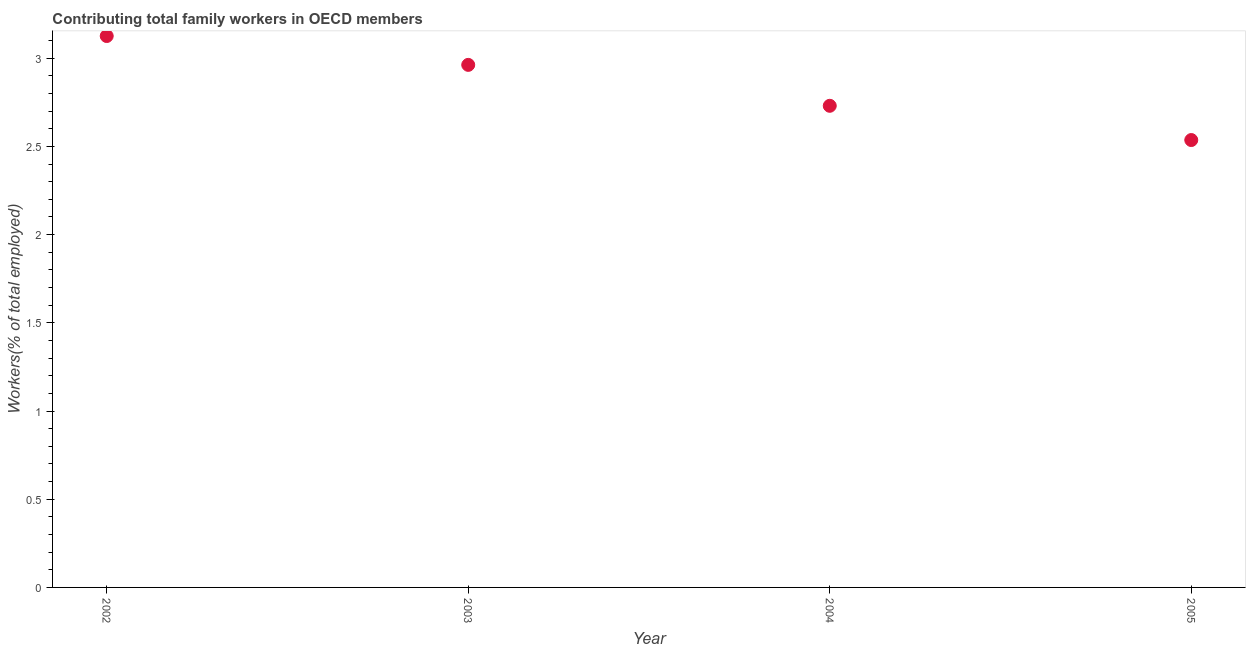What is the contributing family workers in 2004?
Make the answer very short. 2.73. Across all years, what is the maximum contributing family workers?
Keep it short and to the point. 3.13. Across all years, what is the minimum contributing family workers?
Ensure brevity in your answer.  2.54. In which year was the contributing family workers maximum?
Your answer should be very brief. 2002. What is the sum of the contributing family workers?
Offer a very short reply. 11.36. What is the difference between the contributing family workers in 2003 and 2004?
Ensure brevity in your answer.  0.23. What is the average contributing family workers per year?
Provide a succinct answer. 2.84. What is the median contributing family workers?
Provide a short and direct response. 2.85. What is the ratio of the contributing family workers in 2002 to that in 2004?
Your response must be concise. 1.14. Is the contributing family workers in 2003 less than that in 2005?
Offer a very short reply. No. Is the difference between the contributing family workers in 2002 and 2003 greater than the difference between any two years?
Ensure brevity in your answer.  No. What is the difference between the highest and the second highest contributing family workers?
Offer a terse response. 0.16. What is the difference between the highest and the lowest contributing family workers?
Keep it short and to the point. 0.59. Does the contributing family workers monotonically increase over the years?
Keep it short and to the point. No. Does the graph contain grids?
Keep it short and to the point. No. What is the title of the graph?
Keep it short and to the point. Contributing total family workers in OECD members. What is the label or title of the Y-axis?
Provide a succinct answer. Workers(% of total employed). What is the Workers(% of total employed) in 2002?
Give a very brief answer. 3.13. What is the Workers(% of total employed) in 2003?
Offer a very short reply. 2.96. What is the Workers(% of total employed) in 2004?
Give a very brief answer. 2.73. What is the Workers(% of total employed) in 2005?
Your answer should be very brief. 2.54. What is the difference between the Workers(% of total employed) in 2002 and 2003?
Provide a short and direct response. 0.16. What is the difference between the Workers(% of total employed) in 2002 and 2004?
Your answer should be compact. 0.4. What is the difference between the Workers(% of total employed) in 2002 and 2005?
Give a very brief answer. 0.59. What is the difference between the Workers(% of total employed) in 2003 and 2004?
Your response must be concise. 0.23. What is the difference between the Workers(% of total employed) in 2003 and 2005?
Your answer should be very brief. 0.43. What is the difference between the Workers(% of total employed) in 2004 and 2005?
Your answer should be compact. 0.19. What is the ratio of the Workers(% of total employed) in 2002 to that in 2003?
Offer a terse response. 1.05. What is the ratio of the Workers(% of total employed) in 2002 to that in 2004?
Provide a short and direct response. 1.15. What is the ratio of the Workers(% of total employed) in 2002 to that in 2005?
Provide a short and direct response. 1.23. What is the ratio of the Workers(% of total employed) in 2003 to that in 2004?
Offer a very short reply. 1.08. What is the ratio of the Workers(% of total employed) in 2003 to that in 2005?
Offer a terse response. 1.17. What is the ratio of the Workers(% of total employed) in 2004 to that in 2005?
Offer a terse response. 1.08. 